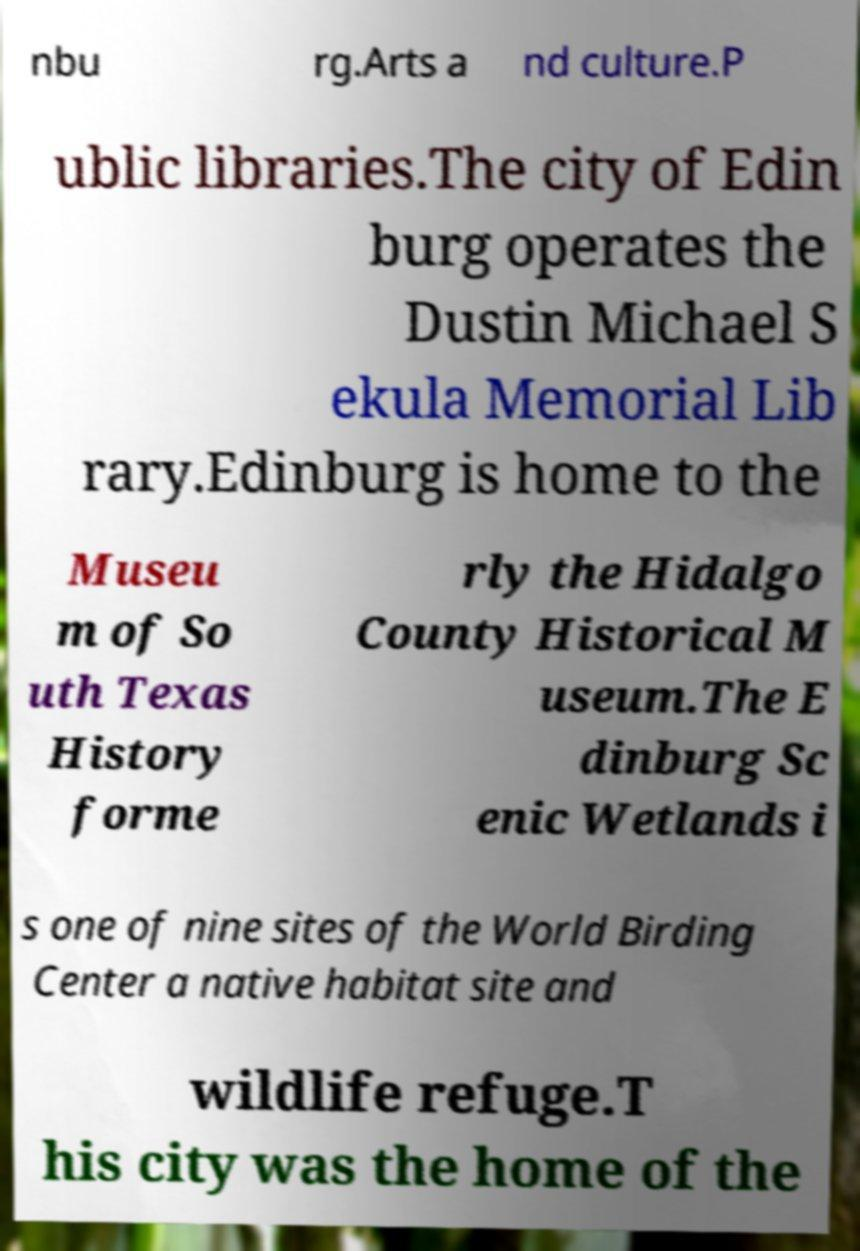There's text embedded in this image that I need extracted. Can you transcribe it verbatim? nbu rg.Arts a nd culture.P ublic libraries.The city of Edin burg operates the Dustin Michael S ekula Memorial Lib rary.Edinburg is home to the Museu m of So uth Texas History forme rly the Hidalgo County Historical M useum.The E dinburg Sc enic Wetlands i s one of nine sites of the World Birding Center a native habitat site and wildlife refuge.T his city was the home of the 